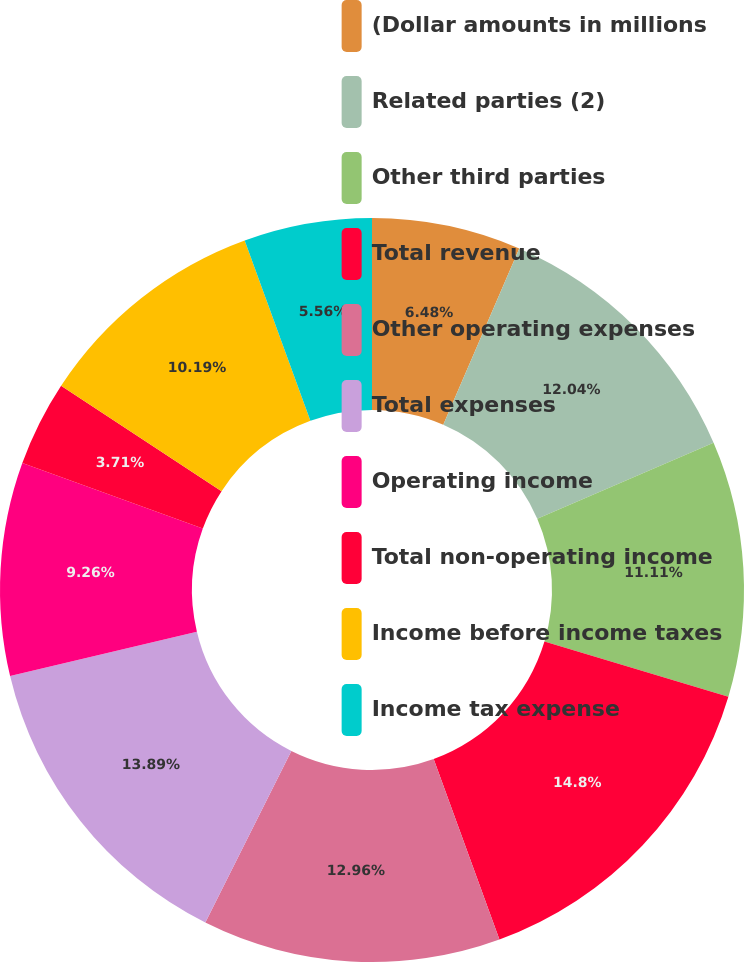<chart> <loc_0><loc_0><loc_500><loc_500><pie_chart><fcel>(Dollar amounts in millions<fcel>Related parties (2)<fcel>Other third parties<fcel>Total revenue<fcel>Other operating expenses<fcel>Total expenses<fcel>Operating income<fcel>Total non-operating income<fcel>Income before income taxes<fcel>Income tax expense<nl><fcel>6.48%<fcel>12.04%<fcel>11.11%<fcel>14.81%<fcel>12.96%<fcel>13.89%<fcel>9.26%<fcel>3.71%<fcel>10.19%<fcel>5.56%<nl></chart> 